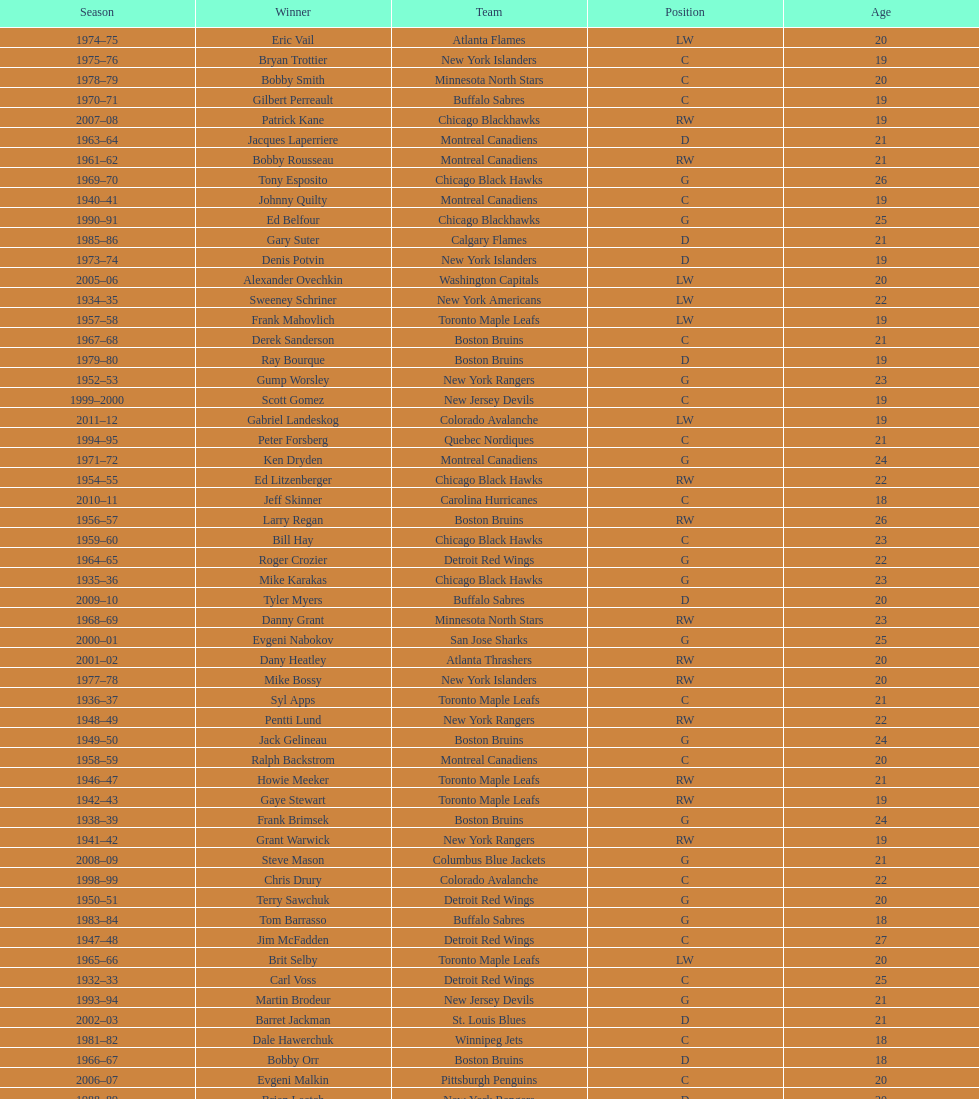Which team has the highest number of consecutive calder memorial trophy winners? Toronto Maple Leafs. 